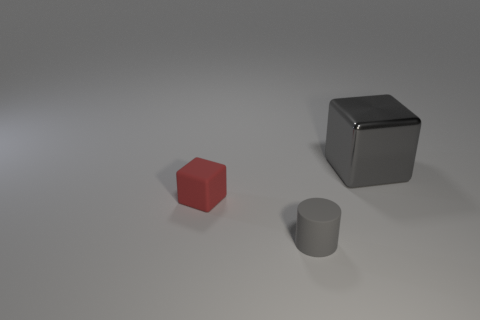Is there anything else that is the same material as the big gray thing?
Ensure brevity in your answer.  No. What is the shape of the other small thing that is the same color as the metal thing?
Your answer should be very brief. Cylinder. How many objects are either small brown matte cylinders or things in front of the large cube?
Provide a succinct answer. 2. Do the rubber thing that is in front of the small rubber cube and the cube in front of the metallic block have the same size?
Give a very brief answer. Yes. What number of other gray shiny objects have the same shape as the large metallic object?
Your answer should be very brief. 0. There is a gray object that is the same material as the tiny red object; what shape is it?
Make the answer very short. Cylinder. There is a gray object that is on the left side of the gray object that is behind the cube left of the large thing; what is its material?
Your response must be concise. Rubber. There is a gray metallic object; does it have the same size as the matte thing that is behind the small gray rubber cylinder?
Offer a very short reply. No. There is a small thing that is the same shape as the big metallic thing; what material is it?
Provide a short and direct response. Rubber. There is a gray thing in front of the gray object behind the gray object in front of the big gray shiny thing; how big is it?
Ensure brevity in your answer.  Small. 